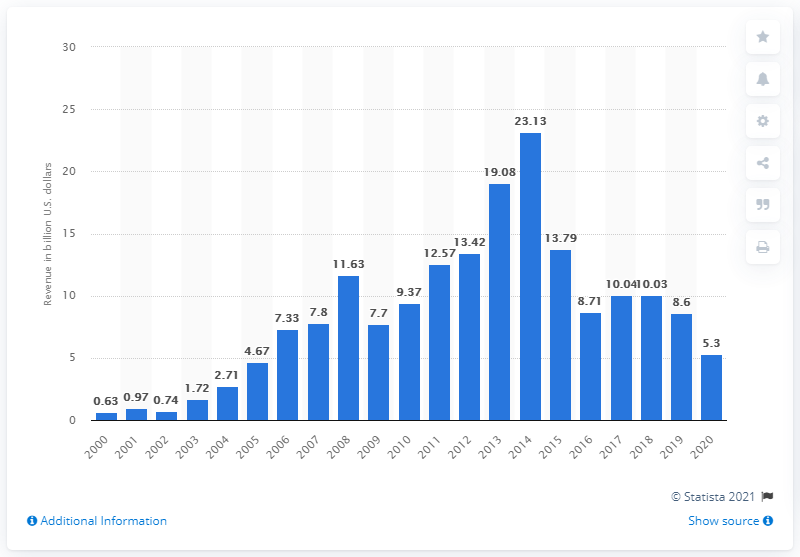Outline some significant characteristics in this image. Chesapeake Energy's revenue in the year prior was 8.6 billion dollars. In 2020, Chesapeake Energy's revenue was 5.3 billion dollars. 